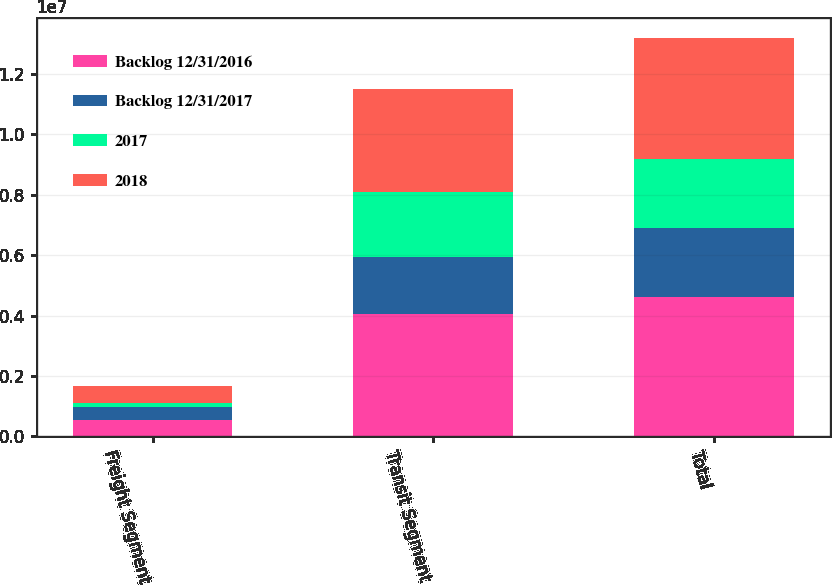<chart> <loc_0><loc_0><loc_500><loc_500><stacked_bar_chart><ecel><fcel>Freight Segment<fcel>Transit Segment<fcel>Total<nl><fcel>Backlog 12/31/2016<fcel>549188<fcel>4.05046e+06<fcel>4.59965e+06<nl><fcel>Backlog 12/31/2017<fcel>423805<fcel>1.89108e+06<fcel>2.31488e+06<nl><fcel>2017<fcel>125383<fcel>2.15938e+06<fcel>2.28476e+06<nl><fcel>2018<fcel>575931<fcel>3.40556e+06<fcel>3.98149e+06<nl></chart> 